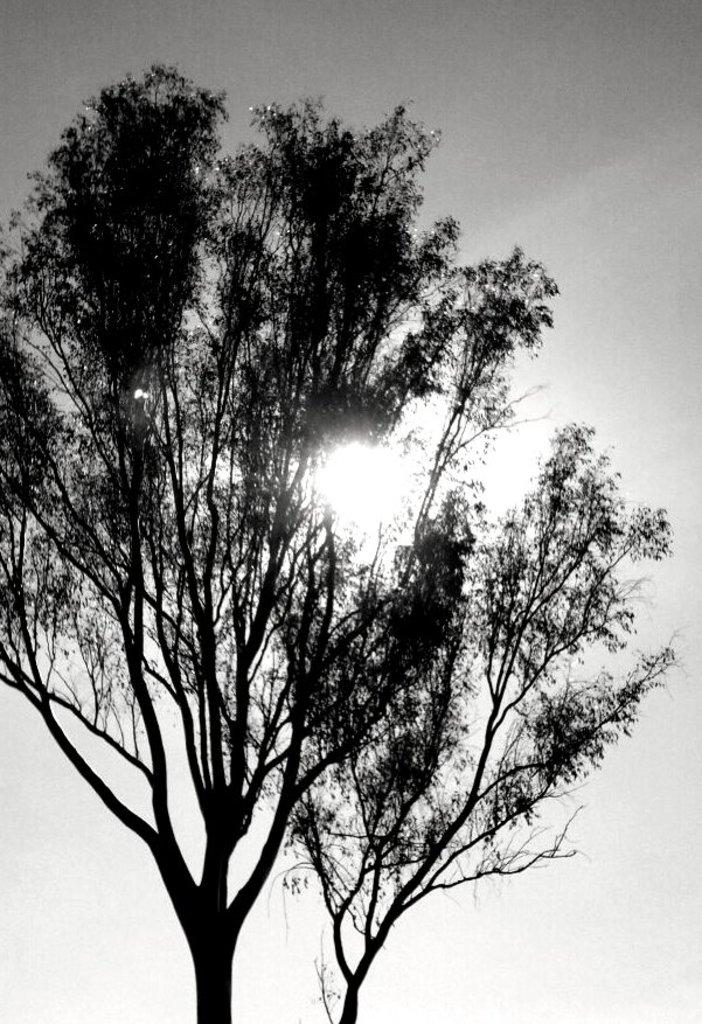What is the color scheme of the image? The image is black and white. What type of natural elements can be seen in the image? There are two trees in the image. What part of the natural environment is visible in the image? The sky is visible in the image. What is the condition of the sky in the image? Sunlight is present in the sky. What type of experience can be seen being pushed in the image? There is no experience or pushing present in the image; it features a black and white scene with two trees and a sunlit sky. 